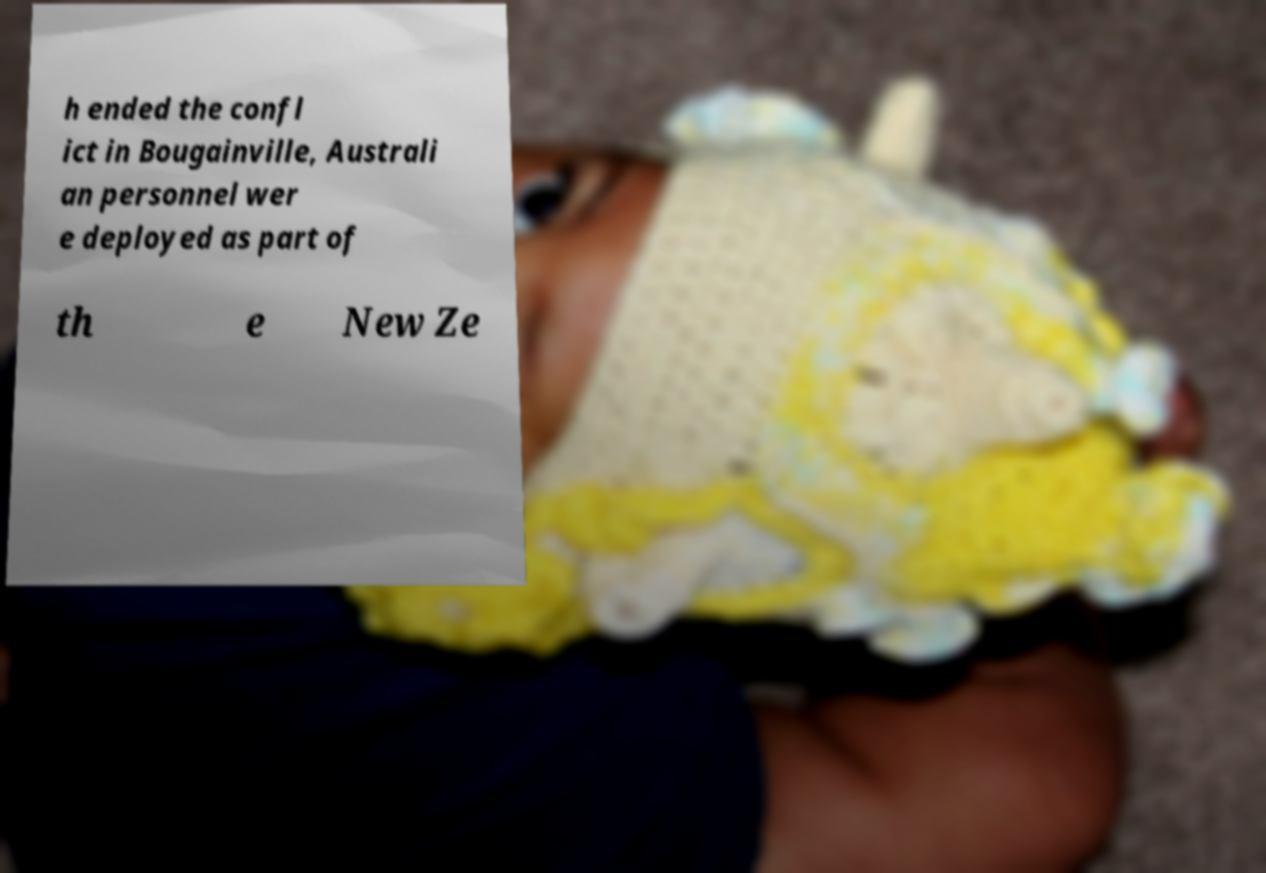Can you accurately transcribe the text from the provided image for me? h ended the confl ict in Bougainville, Australi an personnel wer e deployed as part of th e New Ze 